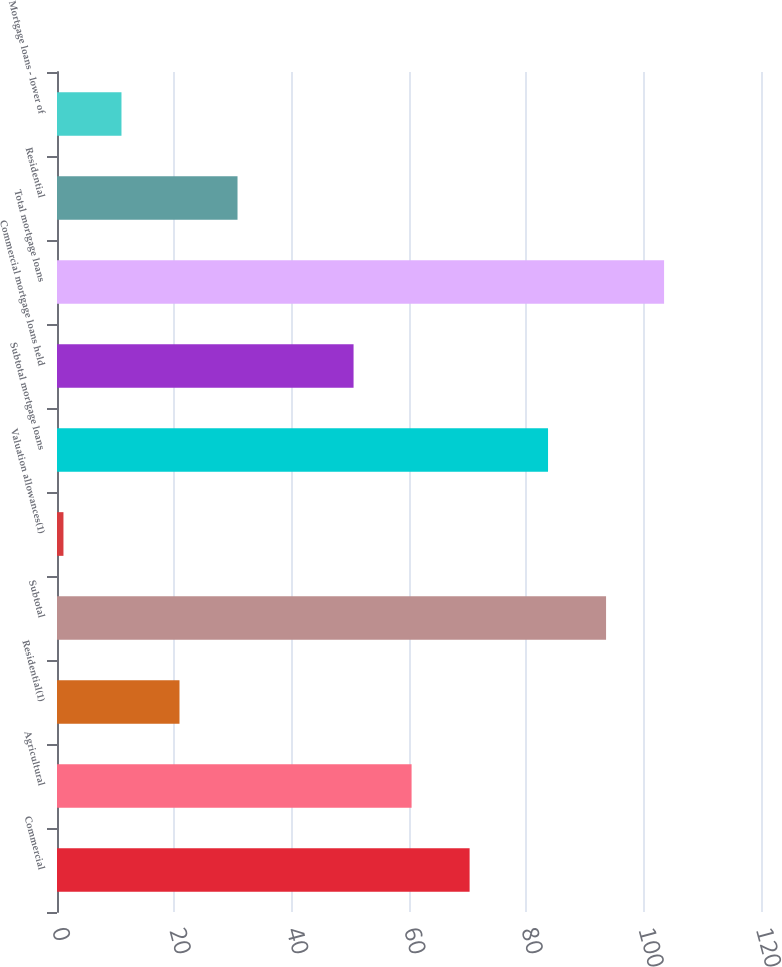<chart> <loc_0><loc_0><loc_500><loc_500><bar_chart><fcel>Commercial<fcel>Agricultural<fcel>Residential(1)<fcel>Subtotal<fcel>Valuation allowances(1)<fcel>Subtotal mortgage loans<fcel>Commercial mortgage loans held<fcel>Total mortgage loans<fcel>Residential<fcel>Mortgage loans - lower of<nl><fcel>70.33<fcel>60.44<fcel>20.88<fcel>93.59<fcel>1.1<fcel>83.7<fcel>50.55<fcel>103.48<fcel>30.77<fcel>10.99<nl></chart> 